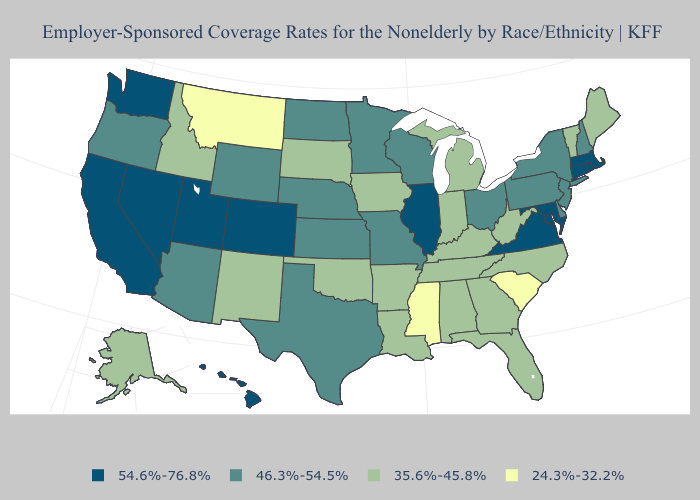What is the value of Pennsylvania?
Quick response, please. 46.3%-54.5%. Does Georgia have the same value as Wyoming?
Short answer required. No. What is the highest value in the West ?
Answer briefly. 54.6%-76.8%. What is the highest value in states that border Vermont?
Write a very short answer. 54.6%-76.8%. Name the states that have a value in the range 46.3%-54.5%?
Write a very short answer. Arizona, Delaware, Kansas, Minnesota, Missouri, Nebraska, New Hampshire, New Jersey, New York, North Dakota, Ohio, Oregon, Pennsylvania, Texas, Wisconsin, Wyoming. Among the states that border Iowa , which have the highest value?
Short answer required. Illinois. What is the value of Arizona?
Give a very brief answer. 46.3%-54.5%. Name the states that have a value in the range 46.3%-54.5%?
Quick response, please. Arizona, Delaware, Kansas, Minnesota, Missouri, Nebraska, New Hampshire, New Jersey, New York, North Dakota, Ohio, Oregon, Pennsylvania, Texas, Wisconsin, Wyoming. Is the legend a continuous bar?
Write a very short answer. No. What is the lowest value in the USA?
Keep it brief. 24.3%-32.2%. Which states have the lowest value in the USA?
Be succinct. Mississippi, Montana, South Carolina. Is the legend a continuous bar?
Write a very short answer. No. Name the states that have a value in the range 24.3%-32.2%?
Write a very short answer. Mississippi, Montana, South Carolina. Which states have the highest value in the USA?
Quick response, please. California, Colorado, Connecticut, Hawaii, Illinois, Maryland, Massachusetts, Nevada, Rhode Island, Utah, Virginia, Washington. Name the states that have a value in the range 24.3%-32.2%?
Short answer required. Mississippi, Montana, South Carolina. 